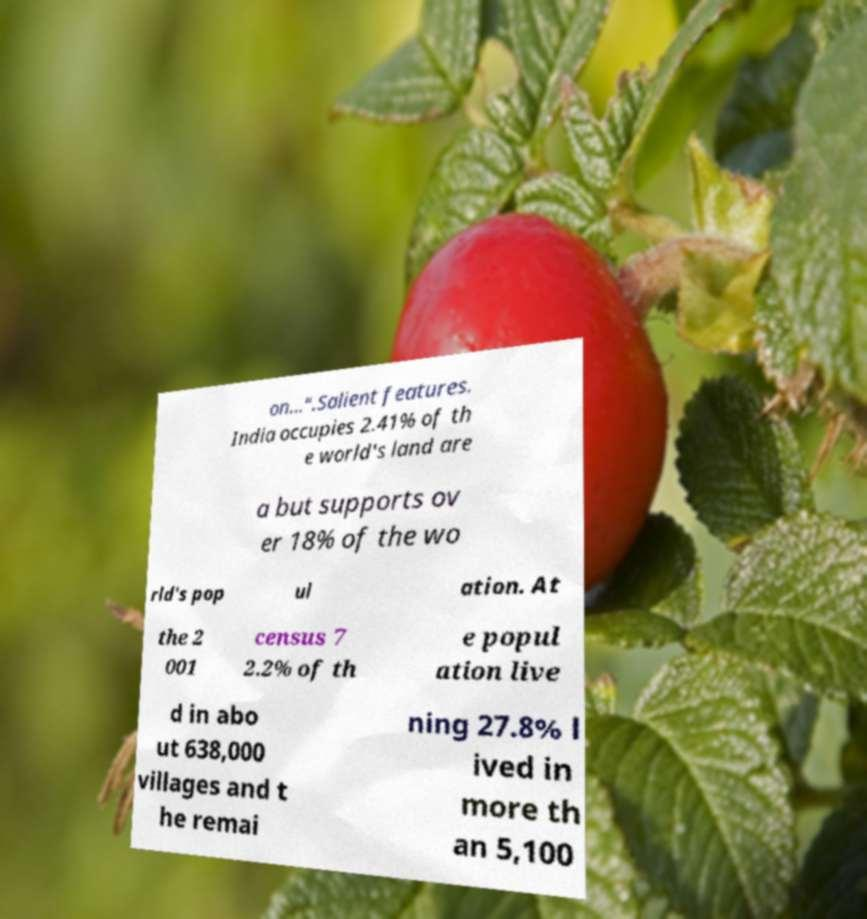Could you assist in decoding the text presented in this image and type it out clearly? on…".Salient features. India occupies 2.41% of th e world's land are a but supports ov er 18% of the wo rld's pop ul ation. At the 2 001 census 7 2.2% of th e popul ation live d in abo ut 638,000 villages and t he remai ning 27.8% l ived in more th an 5,100 